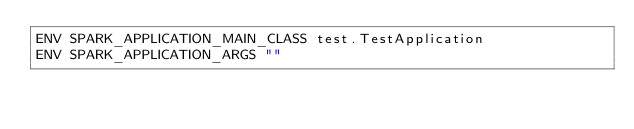Convert code to text. <code><loc_0><loc_0><loc_500><loc_500><_Dockerfile_>ENV SPARK_APPLICATION_MAIN_CLASS test.TestApplication
ENV SPARK_APPLICATION_ARGS ""
</code> 